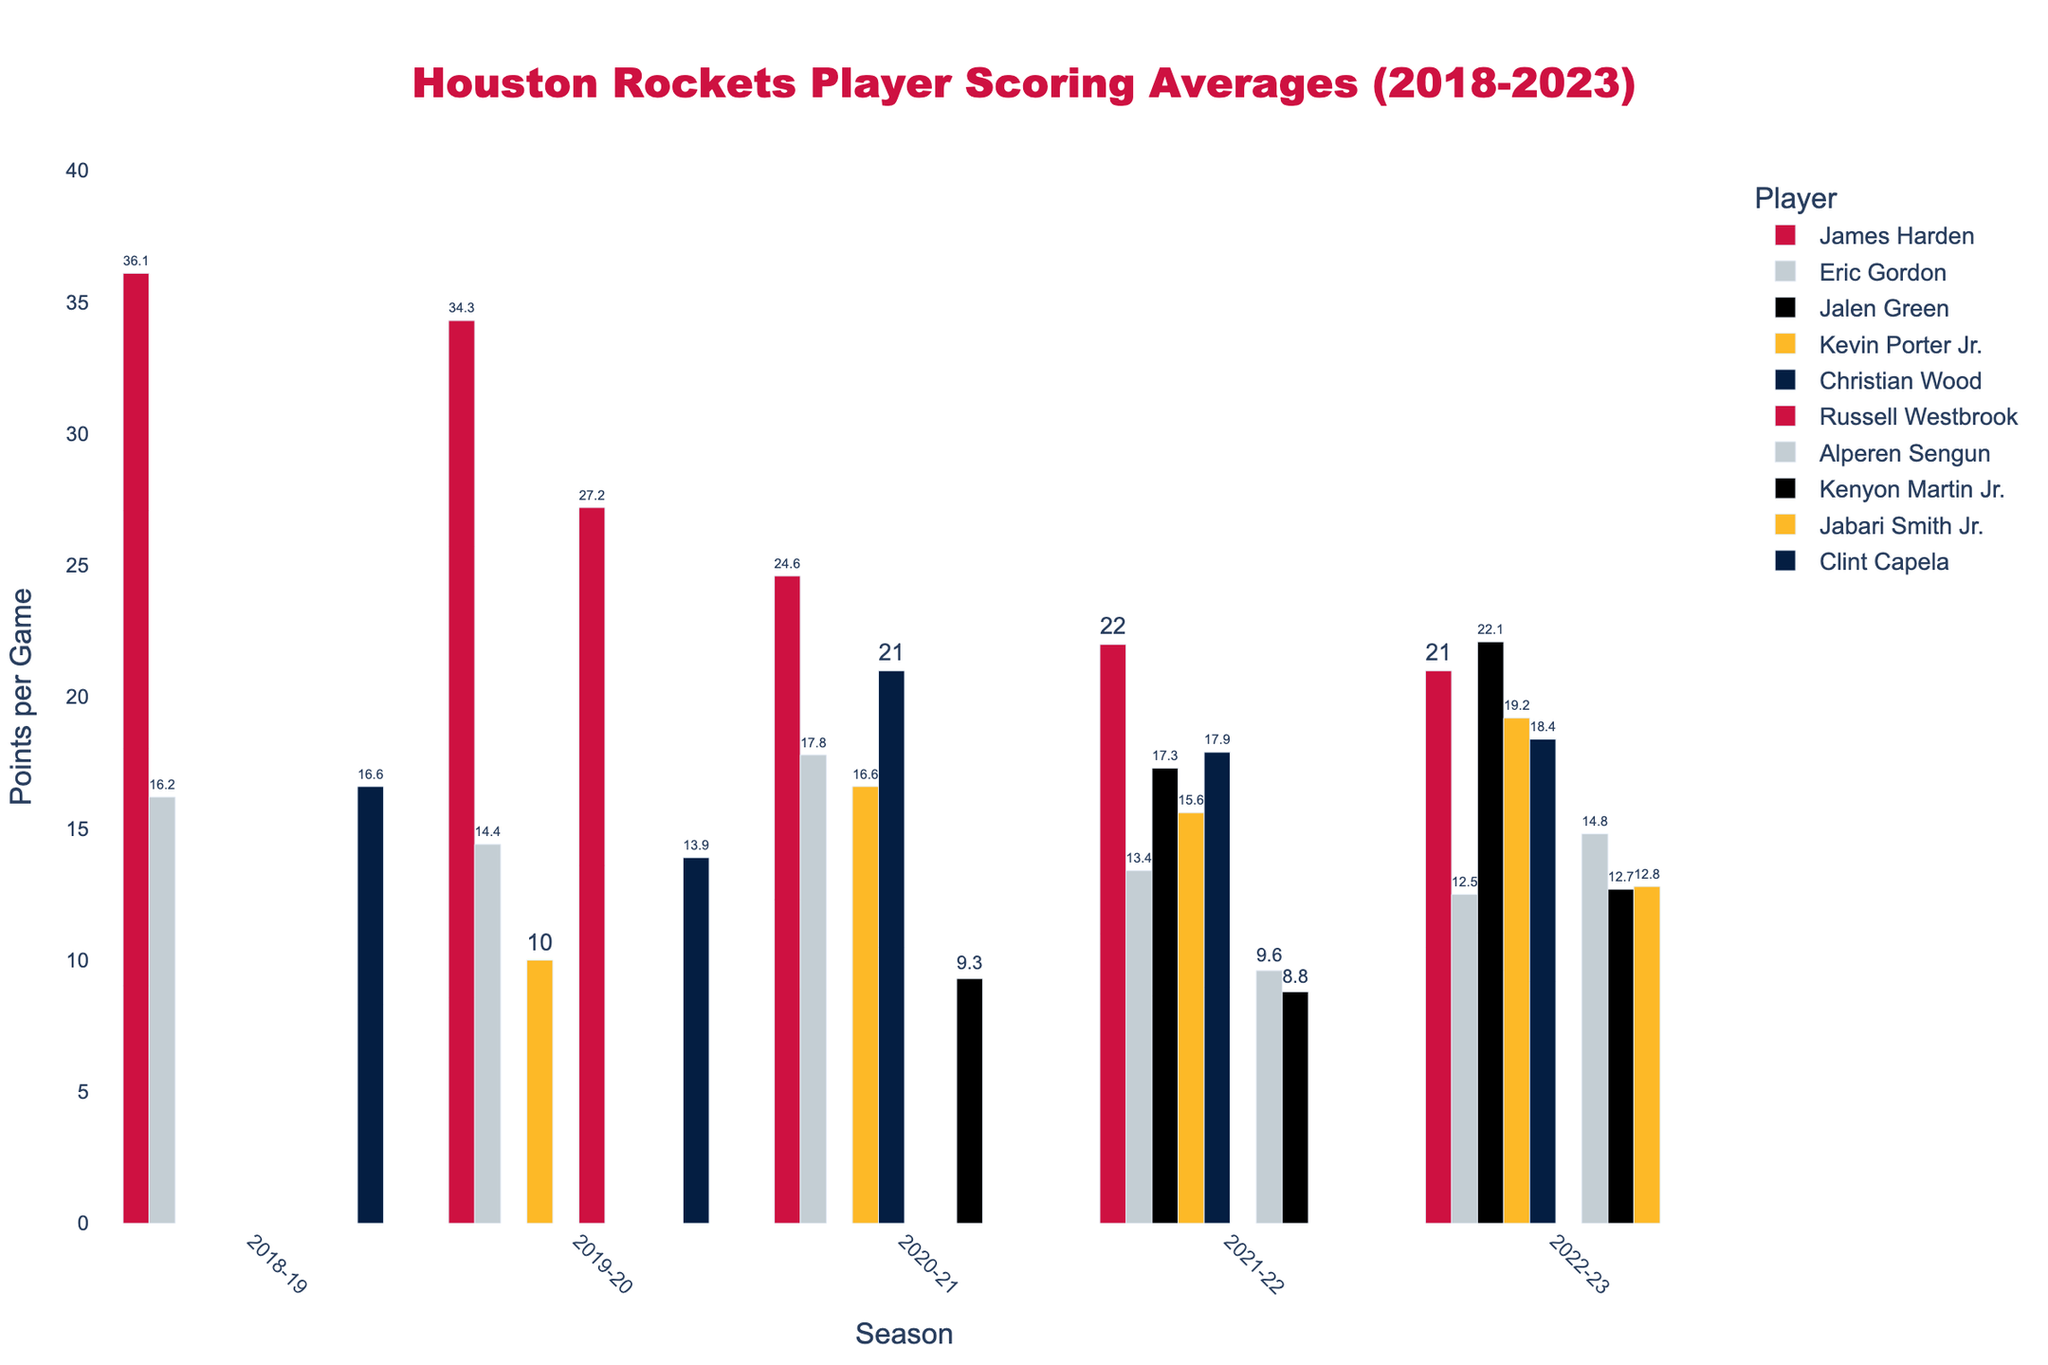How many players had an average scoring above 20 points per game in at least one season? First, identify the players from the bar chart who had average scores above 20 points. James Harden (all seasons), Russell Westbrook (2019-20), Christian Wood (2020-21), and Jalen Green (2022-23) fit this criteria. Therefore, 4 players exceeded 20 points per game in at least one season.
Answer: 4 Which player showed the most consistent scoring pattern over the seasons? Look for players with the smallest variation in their scoring averages across the displayed seasons. Eric Gordon's scores ranged from 12.5 to 17.8, a small range compared to others.
Answer: Eric Gordon Whose highest scoring average occurred in the final season (2022-23)? Compare all players’ highest scoring averages in 2022-23. Jalen Green has the highest in 2022-23 with 22.1 points per game.
Answer: Jalen Green What was the average scoring decline of James Harden from 2018-19 to 2022-23? Calculate the difference in James Harden's scoring from 2018-19 (36.1) to 2022-23 (21.0). The decline is 36.1 - 21.0 = 15.1.
Answer: 15.1 Which player had the steepest drop in scoring average from one season to the next? Identify players with the largest year-to-year decreases. Clint Capela dropped from 16.6 (2018-19) to 13.9 (2019-20), a decline of 2.7 points, less than James Harden whose largest decline is more. But Russell Westbrook had the largest single-season drop, from 27.2 (2019-20) to not appearing in subsequent seasons.
Answer: Russell Westbrook What is the total scoring average of all players in the 2022-23 season? Sum the 2022-23 scores from the chart: Jalen Green (22.1), Kevin Porter Jr. (19.2), Eric Gordon (12.5), Christian Wood (18.4), Alperen Sengun (14.8), Kenyon Martin Jr. (12.7), and Jabari Smith Jr. (12.8). Total = 22.1 + 19.2 + 18.4 + 14.8 + 12.7 + 12.8 + 12.5 = 112.5
Answer: 112.5 Which player had the highest scoring average in a single season and what was it? Identify the player with the tallest bar. James Harden had the highest scoring average in the 2018-19 season, scoring 36.1 points per game.
Answer: James Harden, 36.1 Compare the scoring averages of Kevin Porter Jr. and Eric Gordon in the 2020-21 season. Who scored more and by how much? From the chart, Kevin Porter Jr. scored 16.6 and Eric Gordon scored 17.8 in 2020-21. Gordon scored more. Difference: 17.8 - 16.6 = 1.2.
Answer: Eric Gordon, 1.2 Which seasons did Alperen Sengun play, and how did his scoring improve over those seasons? Observe the bars for Alperen Sengun. He played in 2021-22 and 2022-23, increasing from 9.6 points to 14.8 points.
Answer: 2021-22 and 2022-23, improved by 5.2 What was Clint Capela’s scoring trend between the seasons he played? Look at Clint Capela’s bars; his scoring decreased from 16.6 (2018-19) to 13.9 (2019-20).
Answer: Decreased 